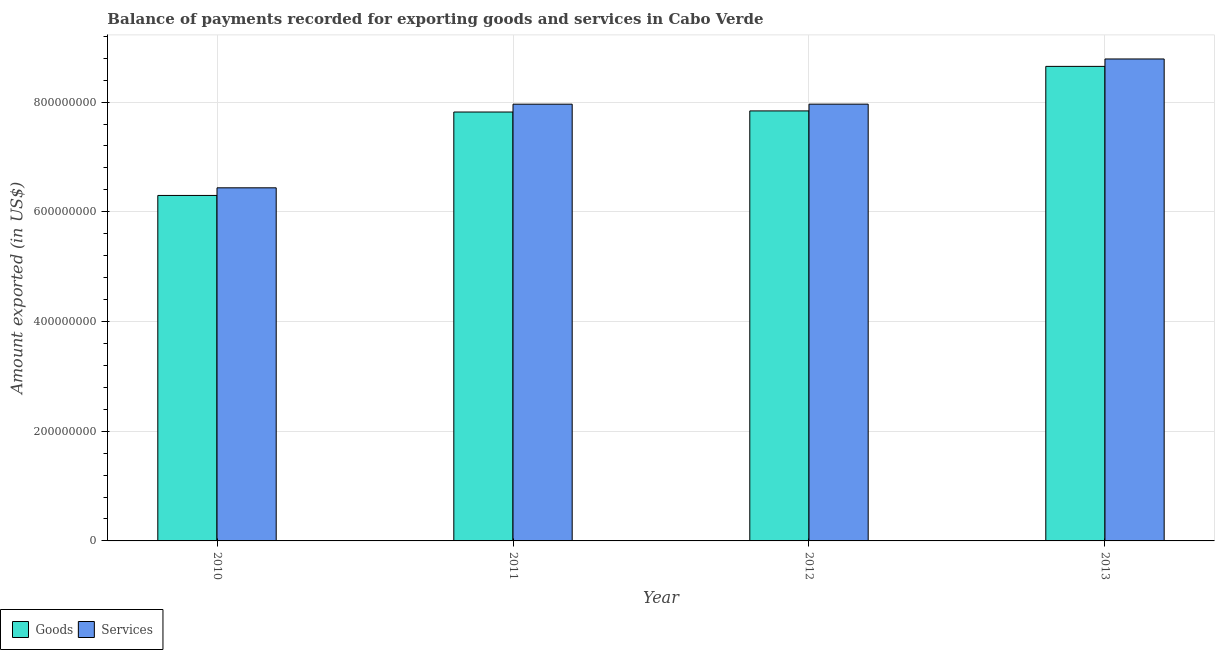How many groups of bars are there?
Your answer should be compact. 4. Are the number of bars per tick equal to the number of legend labels?
Give a very brief answer. Yes. How many bars are there on the 2nd tick from the left?
Offer a terse response. 2. How many bars are there on the 3rd tick from the right?
Give a very brief answer. 2. What is the label of the 4th group of bars from the left?
Give a very brief answer. 2013. In how many cases, is the number of bars for a given year not equal to the number of legend labels?
Provide a short and direct response. 0. What is the amount of services exported in 2010?
Your response must be concise. 6.44e+08. Across all years, what is the maximum amount of services exported?
Your answer should be compact. 8.79e+08. Across all years, what is the minimum amount of services exported?
Offer a terse response. 6.44e+08. In which year was the amount of goods exported maximum?
Your response must be concise. 2013. What is the total amount of goods exported in the graph?
Ensure brevity in your answer.  3.06e+09. What is the difference between the amount of services exported in 2010 and that in 2012?
Offer a very short reply. -1.53e+08. What is the difference between the amount of goods exported in 2013 and the amount of services exported in 2011?
Provide a succinct answer. 8.32e+07. What is the average amount of services exported per year?
Your answer should be very brief. 7.79e+08. In the year 2012, what is the difference between the amount of services exported and amount of goods exported?
Provide a short and direct response. 0. In how many years, is the amount of services exported greater than 80000000 US$?
Your answer should be compact. 4. What is the ratio of the amount of goods exported in 2011 to that in 2012?
Give a very brief answer. 1. Is the difference between the amount of goods exported in 2012 and 2013 greater than the difference between the amount of services exported in 2012 and 2013?
Provide a short and direct response. No. What is the difference between the highest and the second highest amount of services exported?
Your answer should be compact. 8.24e+07. What is the difference between the highest and the lowest amount of services exported?
Your response must be concise. 2.35e+08. What does the 2nd bar from the left in 2011 represents?
Offer a terse response. Services. What does the 1st bar from the right in 2010 represents?
Make the answer very short. Services. How many bars are there?
Make the answer very short. 8. How many years are there in the graph?
Give a very brief answer. 4. Are the values on the major ticks of Y-axis written in scientific E-notation?
Make the answer very short. No. How many legend labels are there?
Your answer should be compact. 2. How are the legend labels stacked?
Give a very brief answer. Horizontal. What is the title of the graph?
Your response must be concise. Balance of payments recorded for exporting goods and services in Cabo Verde. What is the label or title of the X-axis?
Make the answer very short. Year. What is the label or title of the Y-axis?
Provide a succinct answer. Amount exported (in US$). What is the Amount exported (in US$) of Goods in 2010?
Provide a succinct answer. 6.30e+08. What is the Amount exported (in US$) of Services in 2010?
Offer a terse response. 6.44e+08. What is the Amount exported (in US$) of Goods in 2011?
Offer a terse response. 7.82e+08. What is the Amount exported (in US$) of Services in 2011?
Ensure brevity in your answer.  7.96e+08. What is the Amount exported (in US$) of Goods in 2012?
Give a very brief answer. 7.84e+08. What is the Amount exported (in US$) of Services in 2012?
Give a very brief answer. 7.96e+08. What is the Amount exported (in US$) in Goods in 2013?
Offer a very short reply. 8.65e+08. What is the Amount exported (in US$) in Services in 2013?
Your answer should be compact. 8.79e+08. Across all years, what is the maximum Amount exported (in US$) of Goods?
Your answer should be compact. 8.65e+08. Across all years, what is the maximum Amount exported (in US$) in Services?
Make the answer very short. 8.79e+08. Across all years, what is the minimum Amount exported (in US$) in Goods?
Keep it short and to the point. 6.30e+08. Across all years, what is the minimum Amount exported (in US$) in Services?
Your response must be concise. 6.44e+08. What is the total Amount exported (in US$) in Goods in the graph?
Your answer should be compact. 3.06e+09. What is the total Amount exported (in US$) in Services in the graph?
Offer a terse response. 3.11e+09. What is the difference between the Amount exported (in US$) in Goods in 2010 and that in 2011?
Your answer should be compact. -1.52e+08. What is the difference between the Amount exported (in US$) of Services in 2010 and that in 2011?
Make the answer very short. -1.52e+08. What is the difference between the Amount exported (in US$) in Goods in 2010 and that in 2012?
Provide a short and direct response. -1.54e+08. What is the difference between the Amount exported (in US$) in Services in 2010 and that in 2012?
Make the answer very short. -1.53e+08. What is the difference between the Amount exported (in US$) of Goods in 2010 and that in 2013?
Keep it short and to the point. -2.35e+08. What is the difference between the Amount exported (in US$) of Services in 2010 and that in 2013?
Your answer should be very brief. -2.35e+08. What is the difference between the Amount exported (in US$) of Goods in 2011 and that in 2012?
Make the answer very short. -2.00e+06. What is the difference between the Amount exported (in US$) of Services in 2011 and that in 2012?
Your response must be concise. -5.88e+04. What is the difference between the Amount exported (in US$) in Goods in 2011 and that in 2013?
Provide a succinct answer. -8.32e+07. What is the difference between the Amount exported (in US$) of Services in 2011 and that in 2013?
Your answer should be compact. -8.24e+07. What is the difference between the Amount exported (in US$) in Goods in 2012 and that in 2013?
Make the answer very short. -8.12e+07. What is the difference between the Amount exported (in US$) of Services in 2012 and that in 2013?
Your answer should be very brief. -8.24e+07. What is the difference between the Amount exported (in US$) in Goods in 2010 and the Amount exported (in US$) in Services in 2011?
Offer a very short reply. -1.66e+08. What is the difference between the Amount exported (in US$) of Goods in 2010 and the Amount exported (in US$) of Services in 2012?
Your response must be concise. -1.66e+08. What is the difference between the Amount exported (in US$) of Goods in 2010 and the Amount exported (in US$) of Services in 2013?
Offer a very short reply. -2.49e+08. What is the difference between the Amount exported (in US$) of Goods in 2011 and the Amount exported (in US$) of Services in 2012?
Your answer should be compact. -1.43e+07. What is the difference between the Amount exported (in US$) of Goods in 2011 and the Amount exported (in US$) of Services in 2013?
Your answer should be very brief. -9.67e+07. What is the difference between the Amount exported (in US$) in Goods in 2012 and the Amount exported (in US$) in Services in 2013?
Your answer should be very brief. -9.47e+07. What is the average Amount exported (in US$) of Goods per year?
Provide a succinct answer. 7.65e+08. What is the average Amount exported (in US$) of Services per year?
Your response must be concise. 7.79e+08. In the year 2010, what is the difference between the Amount exported (in US$) in Goods and Amount exported (in US$) in Services?
Your answer should be compact. -1.39e+07. In the year 2011, what is the difference between the Amount exported (in US$) in Goods and Amount exported (in US$) in Services?
Your answer should be very brief. -1.43e+07. In the year 2012, what is the difference between the Amount exported (in US$) in Goods and Amount exported (in US$) in Services?
Provide a short and direct response. -1.23e+07. In the year 2013, what is the difference between the Amount exported (in US$) in Goods and Amount exported (in US$) in Services?
Make the answer very short. -1.35e+07. What is the ratio of the Amount exported (in US$) in Goods in 2010 to that in 2011?
Provide a succinct answer. 0.81. What is the ratio of the Amount exported (in US$) of Services in 2010 to that in 2011?
Your answer should be compact. 0.81. What is the ratio of the Amount exported (in US$) in Goods in 2010 to that in 2012?
Make the answer very short. 0.8. What is the ratio of the Amount exported (in US$) in Services in 2010 to that in 2012?
Your response must be concise. 0.81. What is the ratio of the Amount exported (in US$) in Goods in 2010 to that in 2013?
Make the answer very short. 0.73. What is the ratio of the Amount exported (in US$) of Services in 2010 to that in 2013?
Give a very brief answer. 0.73. What is the ratio of the Amount exported (in US$) of Services in 2011 to that in 2012?
Offer a terse response. 1. What is the ratio of the Amount exported (in US$) of Goods in 2011 to that in 2013?
Offer a terse response. 0.9. What is the ratio of the Amount exported (in US$) of Services in 2011 to that in 2013?
Your response must be concise. 0.91. What is the ratio of the Amount exported (in US$) of Goods in 2012 to that in 2013?
Offer a very short reply. 0.91. What is the ratio of the Amount exported (in US$) of Services in 2012 to that in 2013?
Ensure brevity in your answer.  0.91. What is the difference between the highest and the second highest Amount exported (in US$) of Goods?
Keep it short and to the point. 8.12e+07. What is the difference between the highest and the second highest Amount exported (in US$) of Services?
Give a very brief answer. 8.24e+07. What is the difference between the highest and the lowest Amount exported (in US$) of Goods?
Your answer should be compact. 2.35e+08. What is the difference between the highest and the lowest Amount exported (in US$) in Services?
Ensure brevity in your answer.  2.35e+08. 